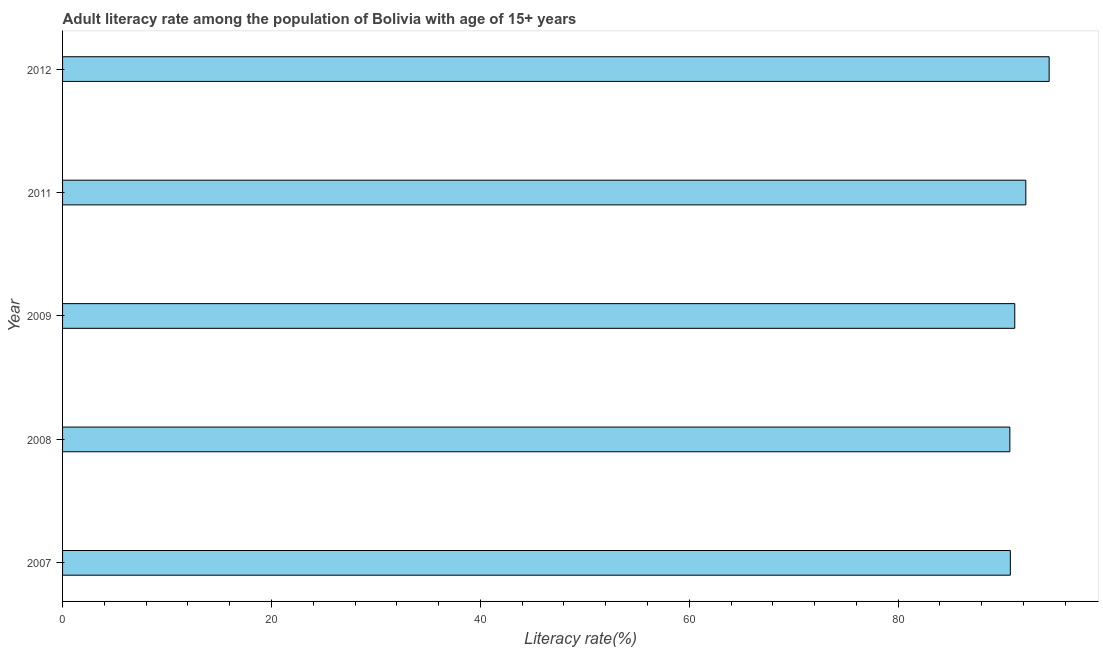Does the graph contain any zero values?
Make the answer very short. No. What is the title of the graph?
Your answer should be very brief. Adult literacy rate among the population of Bolivia with age of 15+ years. What is the label or title of the X-axis?
Your answer should be compact. Literacy rate(%). What is the adult literacy rate in 2011?
Give a very brief answer. 92.23. Across all years, what is the maximum adult literacy rate?
Provide a succinct answer. 94.46. Across all years, what is the minimum adult literacy rate?
Your answer should be very brief. 90.7. In which year was the adult literacy rate maximum?
Provide a short and direct response. 2012. In which year was the adult literacy rate minimum?
Offer a very short reply. 2008. What is the sum of the adult literacy rate?
Make the answer very short. 459.3. What is the difference between the adult literacy rate in 2008 and 2009?
Keep it short and to the point. -0.47. What is the average adult literacy rate per year?
Your answer should be very brief. 91.86. What is the median adult literacy rate?
Provide a short and direct response. 91.17. Do a majority of the years between 2008 and 2009 (inclusive) have adult literacy rate greater than 32 %?
Your response must be concise. Yes. Is the adult literacy rate in 2008 less than that in 2011?
Keep it short and to the point. Yes. What is the difference between the highest and the second highest adult literacy rate?
Offer a very short reply. 2.23. Is the sum of the adult literacy rate in 2011 and 2012 greater than the maximum adult literacy rate across all years?
Offer a very short reply. Yes. What is the difference between the highest and the lowest adult literacy rate?
Your answer should be very brief. 3.76. In how many years, is the adult literacy rate greater than the average adult literacy rate taken over all years?
Ensure brevity in your answer.  2. Are all the bars in the graph horizontal?
Offer a terse response. Yes. What is the difference between two consecutive major ticks on the X-axis?
Your answer should be compact. 20. Are the values on the major ticks of X-axis written in scientific E-notation?
Ensure brevity in your answer.  No. What is the Literacy rate(%) of 2007?
Offer a very short reply. 90.74. What is the Literacy rate(%) in 2008?
Your answer should be very brief. 90.7. What is the Literacy rate(%) of 2009?
Your response must be concise. 91.17. What is the Literacy rate(%) in 2011?
Make the answer very short. 92.23. What is the Literacy rate(%) of 2012?
Offer a very short reply. 94.46. What is the difference between the Literacy rate(%) in 2007 and 2008?
Make the answer very short. 0.05. What is the difference between the Literacy rate(%) in 2007 and 2009?
Keep it short and to the point. -0.42. What is the difference between the Literacy rate(%) in 2007 and 2011?
Provide a short and direct response. -1.48. What is the difference between the Literacy rate(%) in 2007 and 2012?
Provide a succinct answer. -3.72. What is the difference between the Literacy rate(%) in 2008 and 2009?
Offer a terse response. -0.47. What is the difference between the Literacy rate(%) in 2008 and 2011?
Ensure brevity in your answer.  -1.53. What is the difference between the Literacy rate(%) in 2008 and 2012?
Your response must be concise. -3.76. What is the difference between the Literacy rate(%) in 2009 and 2011?
Your answer should be very brief. -1.06. What is the difference between the Literacy rate(%) in 2009 and 2012?
Offer a terse response. -3.29. What is the difference between the Literacy rate(%) in 2011 and 2012?
Offer a terse response. -2.23. What is the ratio of the Literacy rate(%) in 2007 to that in 2009?
Offer a terse response. 0.99. What is the ratio of the Literacy rate(%) in 2007 to that in 2012?
Your answer should be very brief. 0.96. What is the ratio of the Literacy rate(%) in 2008 to that in 2011?
Offer a terse response. 0.98. 